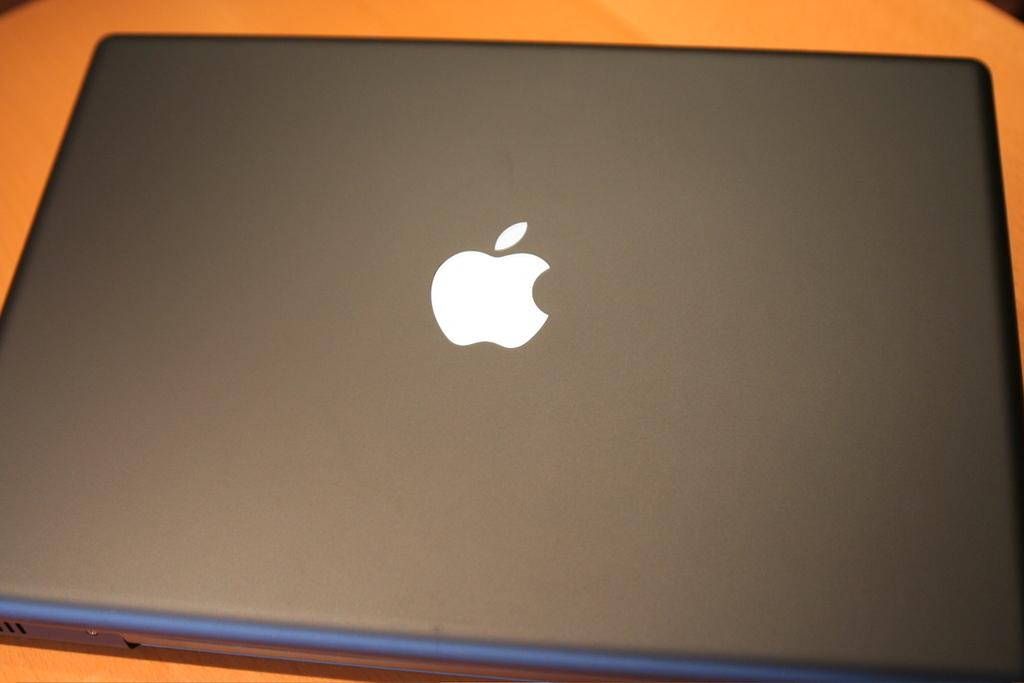What electronic device is present in the image? There is a laptop in the image. On what is the laptop placed? The laptop is placed on an object. What brand of laptop is depicted in the image? The logo of an apple is visible on the laptop, indicating it is a MacBook. What size of pot is used to cook the laptop in the image? There is no pot or cooking activity depicted in the image; it features a laptop placed on an object. 